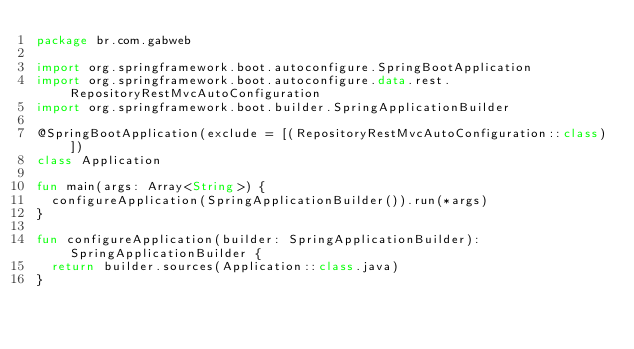Convert code to text. <code><loc_0><loc_0><loc_500><loc_500><_Kotlin_>package br.com.gabweb

import org.springframework.boot.autoconfigure.SpringBootApplication
import org.springframework.boot.autoconfigure.data.rest.RepositoryRestMvcAutoConfiguration
import org.springframework.boot.builder.SpringApplicationBuilder

@SpringBootApplication(exclude = [(RepositoryRestMvcAutoConfiguration::class)])
class Application

fun main(args: Array<String>) {
  configureApplication(SpringApplicationBuilder()).run(*args)
}

fun configureApplication(builder: SpringApplicationBuilder): SpringApplicationBuilder {
  return builder.sources(Application::class.java)
}
</code> 